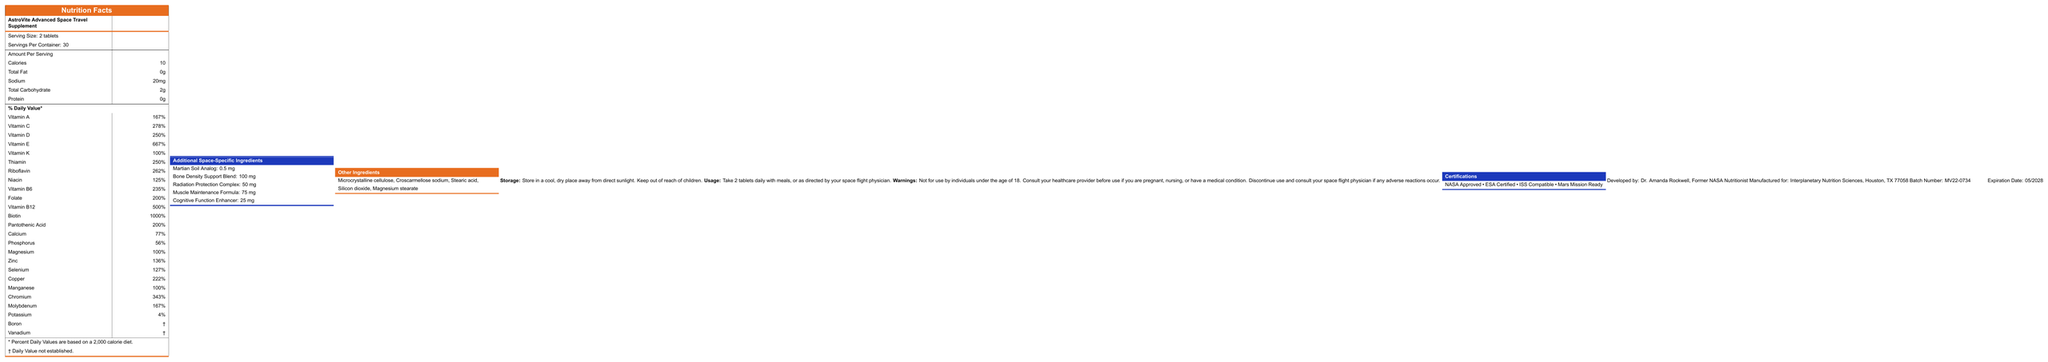what is the product name? The product name is mentioned at the top of the document as "AstroVite Advanced Space Travel Supplement".
Answer: AstroVite Advanced Space Travel Supplement what is the serving size for this supplement? The serving size is indicated in the document as "Serving Size: 2 tablets".
Answer: 2 tablets how many calories are in one serving? The document states "Calories: 10" per serving.
Answer: 10 how much vitamin A does each serving contain? The document lists the amount of Vitamin A per serving as 1500 IU.
Answer: 1500 IU what should you do if you experience adverse reactions? The document provides a warning stating, "Discontinue use and consult your space flight physician if any adverse reactions occur."
Answer: Discontinue use and consult your space flight physician which certification is not mentioned in the document? A. NASA Approved B. ESA Certified C. FDA Approved D. Mars Mission Ready The certifications listed in the document are NASA Approved, ESA Certified, ISS Compatible, and Mars Mission Ready. FDA Approved is not mentioned.
Answer: C. FDA Approved what is the suggested storage condition for the supplement? A. Store in a refrigerator B. Store at room temperature C. Store in a cool, dry place D. Store in a freezer The document instructs, "Store in a cool, dry place away from direct sunlight."
Answer: C. Store in a cool, dry place which of the following vitamins has the highest % Daily Value? A. Vitamin A B. Vitamin E C. Vitamin B12 D. Biotin The % Daily Value for various vitamins is listed, with Biotin having the highest at 1000%.
Answer: D. Biotin is this supplement suitable for individuals under 18 years old? The document clearly states, "Not for use by individuals under the age of 18."
Answer: No summarize the main purpose of this document. The document provides comprehensive information about the AstroVite Advanced Space Travel Supplement, including its nutritional content, special ingredients for space use, storage/usage guidelines, warnings, and certifications to ensure safe and informed usage.
Answer: The document is a Nutrition Facts Label for AstroVite Advanced Space Travel Supplement, detailing serving information, nutritional content, additional space-specific ingredients, storage and usage instructions, warnings, certifications, and manufacturing details. what is the expiration date of the product? The expiration date is provided as "05/2028" in the document.
Answer: 05/2028 who developed this supplement? The document states that the supplement was developed by Dr. Amanda Rockwell, Former NASA Nutritionist.
Answer: Dr. Amanda Rockwell, Former NASA Nutritionist how many servings are included per container? According to the document, there are 30 servings per container.
Answer: 30 what should you do if you are pregnant and considering taking this supplement? The warning section advises consulting your healthcare provider if you are pregnant.
Answer: Consult your healthcare provider how many mg of Martian Soil Analog is included per serving? The document states that each serving contains 0.5 mg of Martian Soil Analog.
Answer: 0.5 mg who manufactured this supplement? The manufacturer is listed as Interplanetary Nutrition Sciences, Houston, TX 77058 in the document.
Answer: Interplanetary Nutrition Sciences, Houston, TX 77058 is the batch number provided in the document? The document includes the batch number: MV22-0734.
Answer: Yes what is the purpose of the Radiation Protection Complex in the supplement? The document does not provide specific details about the purpose or benefits of the Radiation Protection Complex.
Answer: Cannot be determined how should the supplement be taken? The usage instructions recommend taking 2 tablets daily with meals, or as directed by a space flight physician.
Answer: Take 2 tablets daily with meals, or as directed by your space flight physician. 